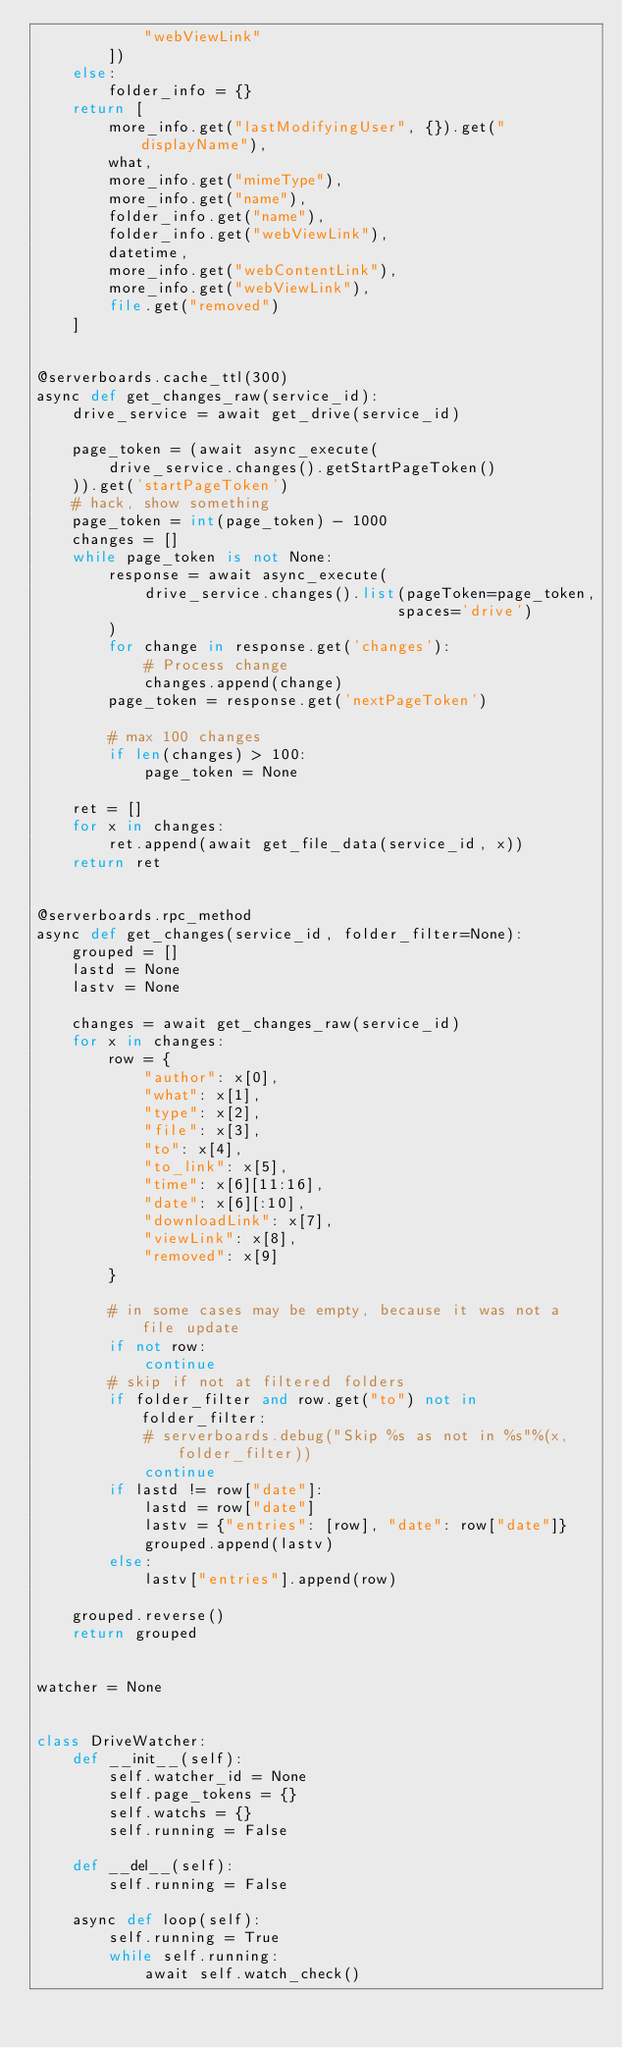<code> <loc_0><loc_0><loc_500><loc_500><_Python_>            "webViewLink"
        ])
    else:
        folder_info = {}
    return [
        more_info.get("lastModifyingUser", {}).get("displayName"),
        what,
        more_info.get("mimeType"),
        more_info.get("name"),
        folder_info.get("name"),
        folder_info.get("webViewLink"),
        datetime,
        more_info.get("webContentLink"),
        more_info.get("webViewLink"),
        file.get("removed")
    ]


@serverboards.cache_ttl(300)
async def get_changes_raw(service_id):
    drive_service = await get_drive(service_id)

    page_token = (await async_execute(
        drive_service.changes().getStartPageToken()
    )).get('startPageToken')
    # hack, show something
    page_token = int(page_token) - 1000
    changes = []
    while page_token is not None:
        response = await async_execute(
            drive_service.changes().list(pageToken=page_token,
                                        spaces='drive')
        )
        for change in response.get('changes'):
            # Process change
            changes.append(change)
        page_token = response.get('nextPageToken')

        # max 100 changes
        if len(changes) > 100:
            page_token = None

    ret = []
    for x in changes:
        ret.append(await get_file_data(service_id, x))
    return ret


@serverboards.rpc_method
async def get_changes(service_id, folder_filter=None):
    grouped = []
    lastd = None
    lastv = None

    changes = await get_changes_raw(service_id)
    for x in changes:
        row = {
            "author": x[0],
            "what": x[1],
            "type": x[2],
            "file": x[3],
            "to": x[4],
            "to_link": x[5],
            "time": x[6][11:16],
            "date": x[6][:10],
            "downloadLink": x[7],
            "viewLink": x[8],
            "removed": x[9]
        }

        # in some cases may be empty, because it was not a file update
        if not row:
            continue
        # skip if not at filtered folders
        if folder_filter and row.get("to") not in folder_filter:
            # serverboards.debug("Skip %s as not in %s"%(x, folder_filter))
            continue
        if lastd != row["date"]:
            lastd = row["date"]
            lastv = {"entries": [row], "date": row["date"]}
            grouped.append(lastv)
        else:
            lastv["entries"].append(row)

    grouped.reverse()
    return grouped


watcher = None


class DriveWatcher:
    def __init__(self):
        self.watcher_id = None
        self.page_tokens = {}
        self.watchs = {}
        self.running = False

    def __del__(self):
        self.running = False

    async def loop(self):
        self.running = True
        while self.running:
            await self.watch_check()</code> 